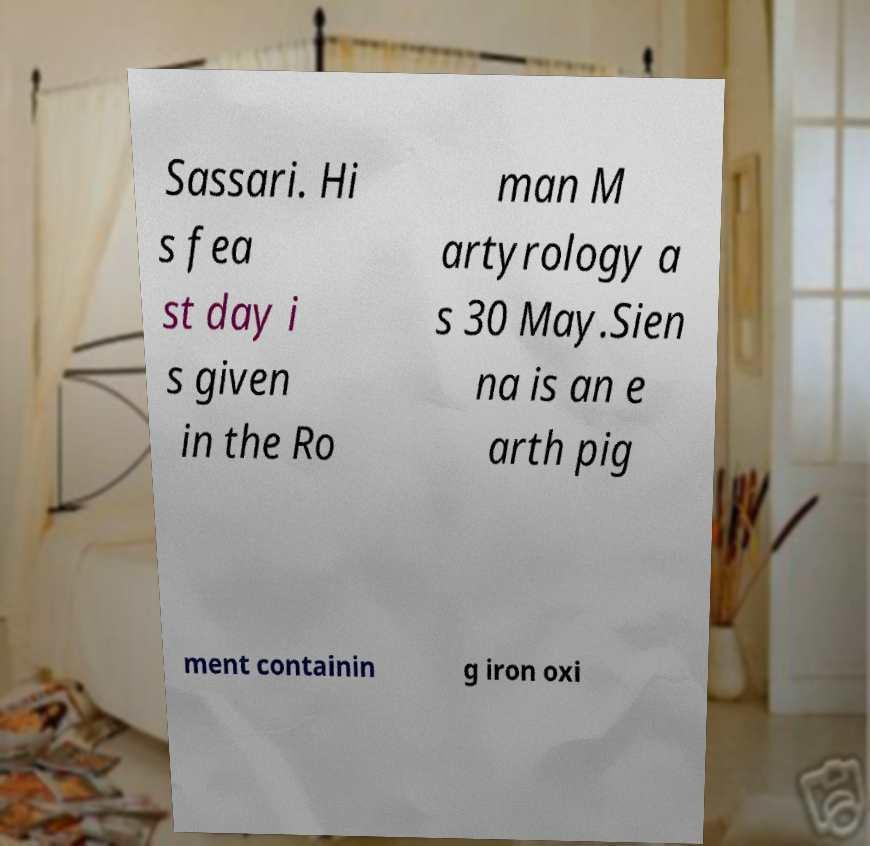Could you extract and type out the text from this image? Sassari. Hi s fea st day i s given in the Ro man M artyrology a s 30 May.Sien na is an e arth pig ment containin g iron oxi 